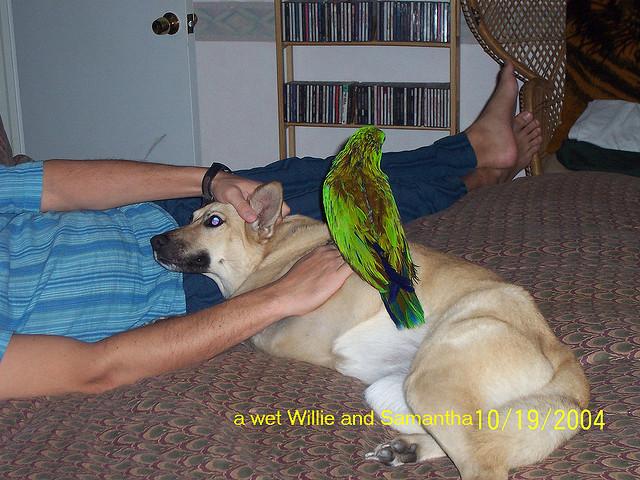How many animals are in this pick?
Keep it brief. 2. Is this dog sick?
Quick response, please. No. What colors make up the bird's feathers?
Write a very short answer. Green. 